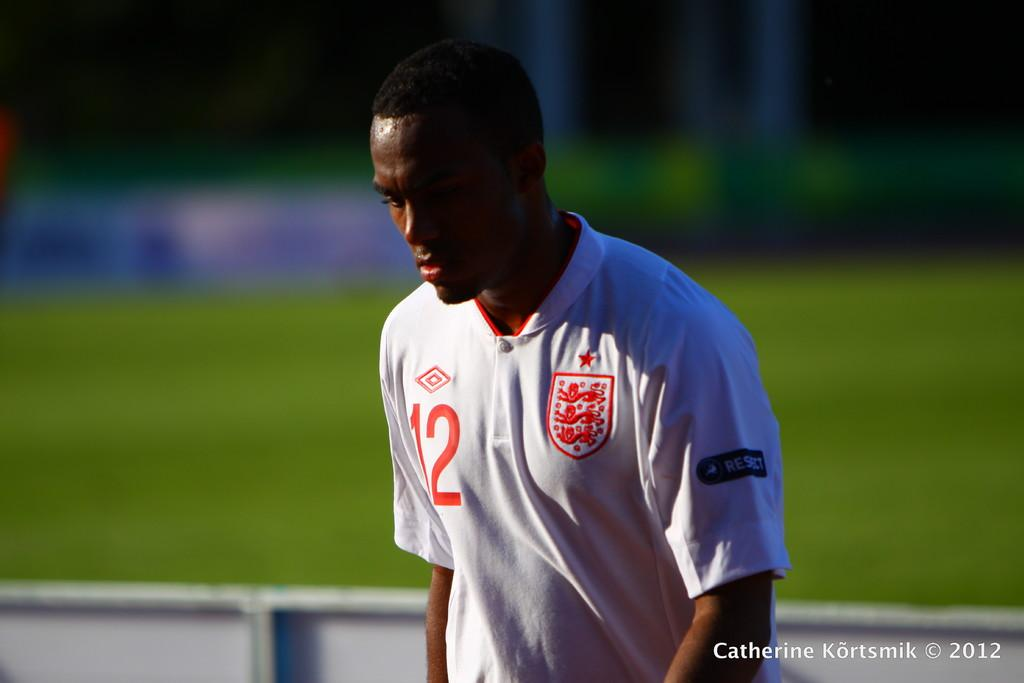Who is present in the image? There is a man in the image. What is the man wearing? The man is wearing a jersey. Can you describe the background of the image? The background of the image is blurred. Is there any additional information or markings on the image? Yes, there is a watermark on the image. What type of trousers is the man wearing in the image? The provided facts do not mention the type of trousers the man is wearing, so we cannot answer this question definitively. What is the weight of the steel used to create the watermark in the image? There is no steel present in the image, and the watermark is likely a digital marking, so we cannot determine the weight of any steel used. 